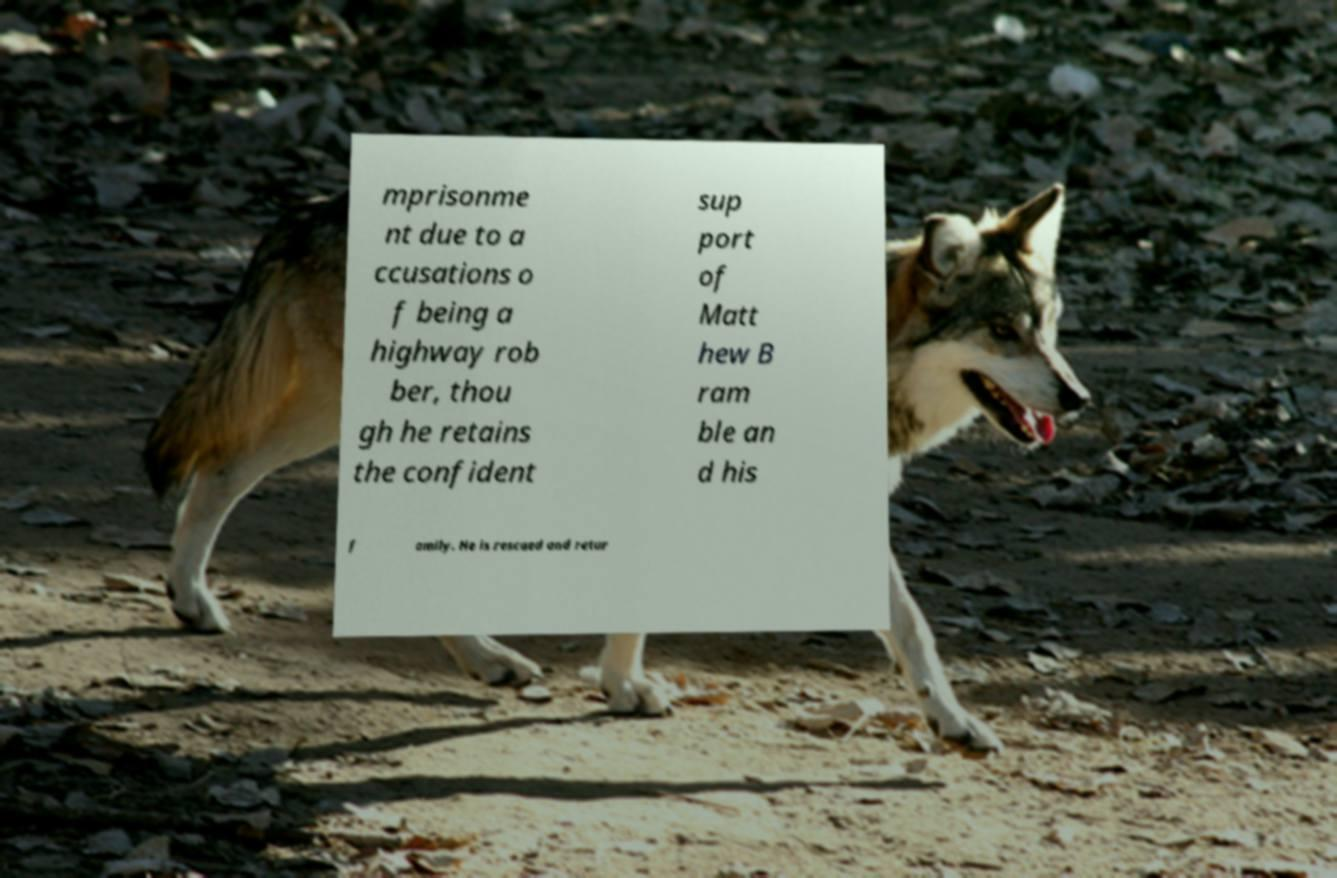For documentation purposes, I need the text within this image transcribed. Could you provide that? mprisonme nt due to a ccusations o f being a highway rob ber, thou gh he retains the confident sup port of Matt hew B ram ble an d his f amily. He is rescued and retur 